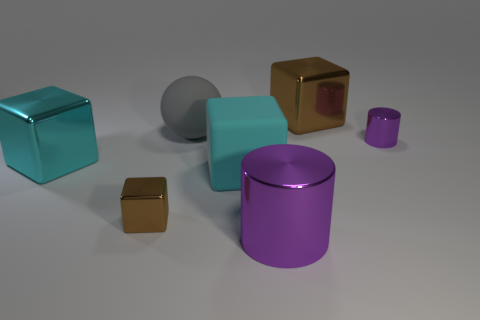Is there a small purple thing made of the same material as the big purple thing?
Provide a short and direct response. Yes. Do the large cyan shiny thing and the big brown thing that is right of the rubber ball have the same shape?
Offer a very short reply. Yes. Are there any big shiny objects behind the large rubber block?
Keep it short and to the point. Yes. How many small objects have the same shape as the large brown metallic thing?
Give a very brief answer. 1. Is the material of the tiny purple thing the same as the brown block that is in front of the big brown block?
Give a very brief answer. Yes. How many tiny cubes are there?
Your response must be concise. 1. There is a metallic thing in front of the small metal block; what size is it?
Ensure brevity in your answer.  Large. What number of other blue matte cubes are the same size as the rubber block?
Give a very brief answer. 0. There is a object that is in front of the cyan matte object and behind the big purple cylinder; what material is it?
Offer a terse response. Metal. There is a sphere that is the same size as the cyan rubber cube; what is its material?
Offer a terse response. Rubber. 